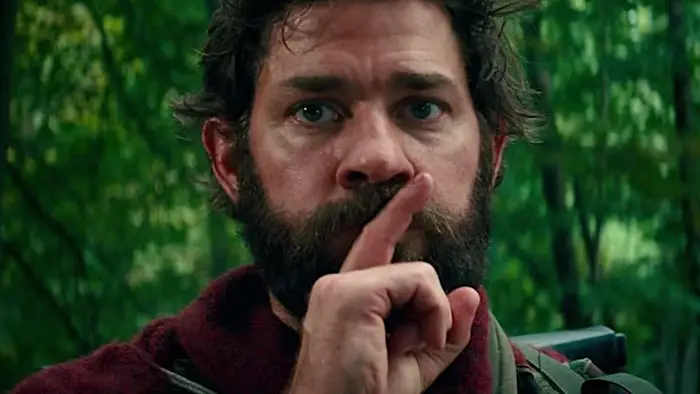What do you see happening in this image? In the image, we see actor John Krasinski, known for his role as Lee Abbott in the movie "A Quiet Place". He is captured in a close-up shot, with his finger pressed to his lips in a universal gesture for silence. His facial expression is serious, reflecting the intense nature of his character and the movie's plot. He sports a beard and is dressed in a red jacket, which stands out against the green forest that forms the backdrop of the image. His gaze is directed towards something or someone off-camera, adding an element of intrigue to the scene. 